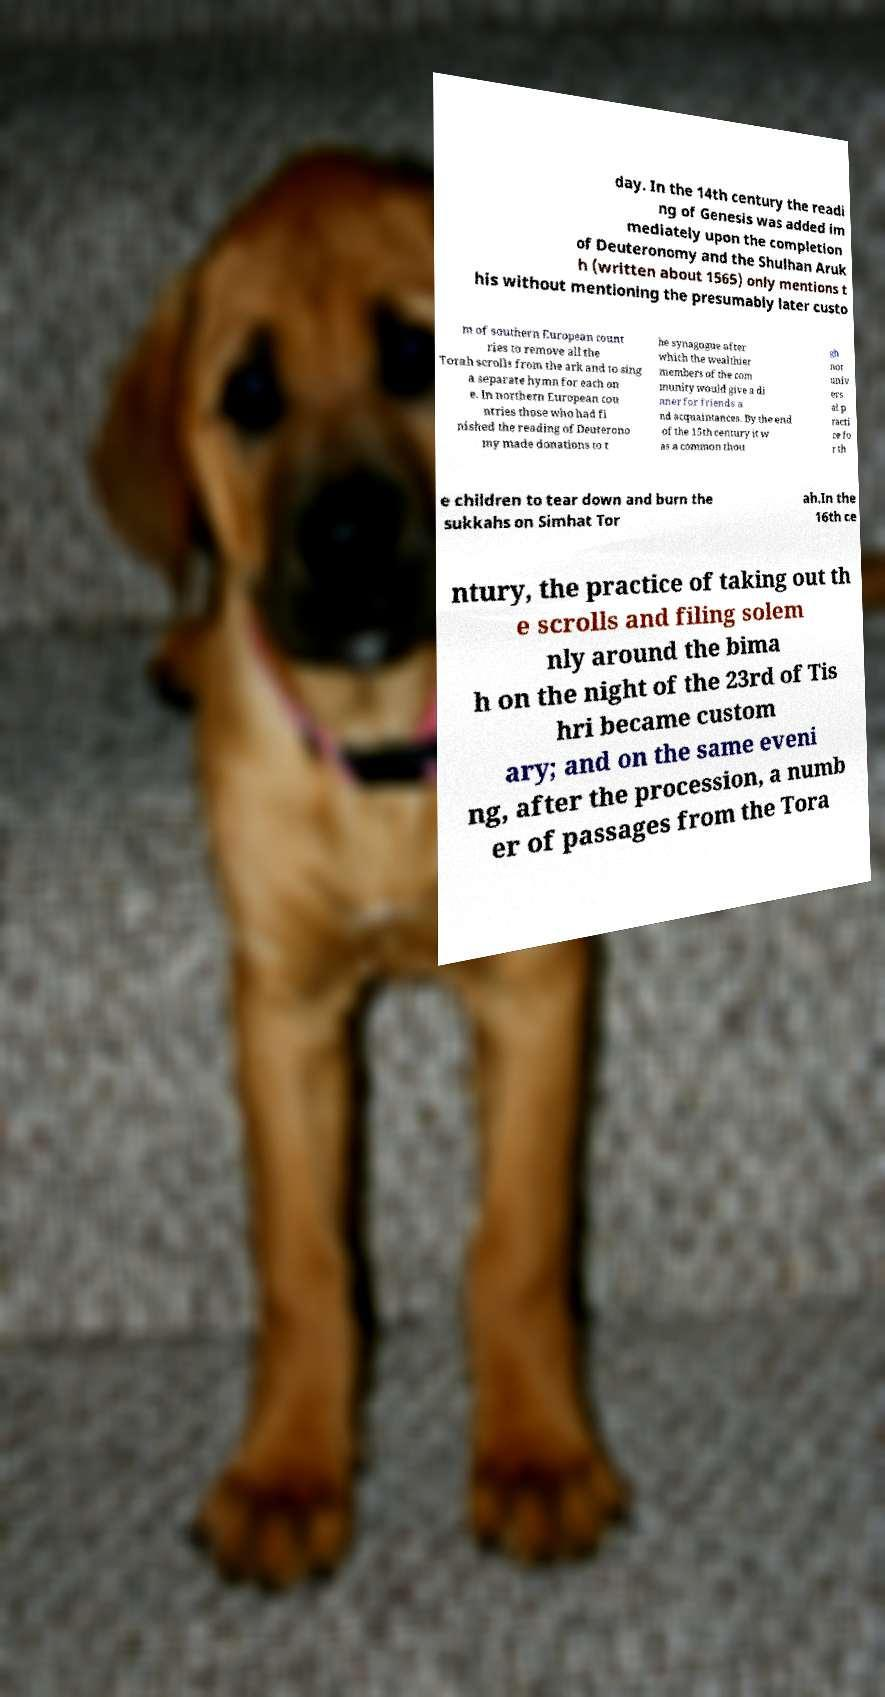Can you read and provide the text displayed in the image?This photo seems to have some interesting text. Can you extract and type it out for me? day. In the 14th century the readi ng of Genesis was added im mediately upon the completion of Deuteronomy and the Shulhan Aruk h (written about 1565) only mentions t his without mentioning the presumably later custo m of southern European count ries to remove all the Torah scrolls from the ark and to sing a separate hymn for each on e. In northern European cou ntries those who had fi nished the reading of Deuterono my made donations to t he synagogue after which the wealthier members of the com munity would give a di nner for friends a nd acquaintances. By the end of the 15th century it w as a common thou gh not univ ers al p racti ce fo r th e children to tear down and burn the sukkahs on Simhat Tor ah.In the 16th ce ntury, the practice of taking out th e scrolls and filing solem nly around the bima h on the night of the 23rd of Tis hri became custom ary; and on the same eveni ng, after the procession, a numb er of passages from the Tora 